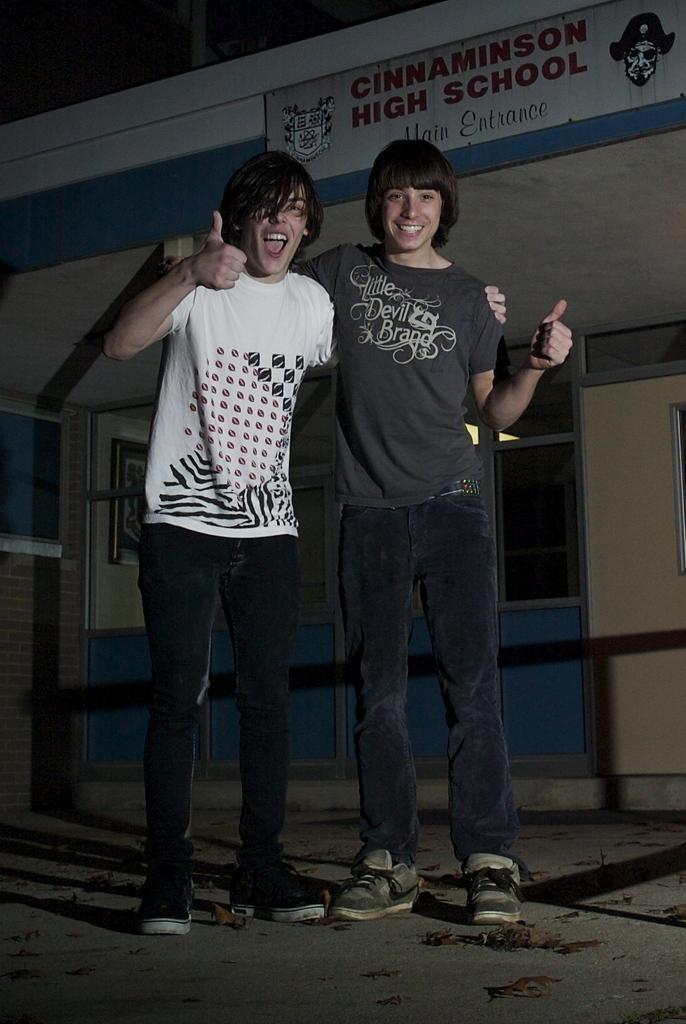Please provide a concise description of this image. In this image we can see two persons standing on the ground and there is a building with text in the background. 